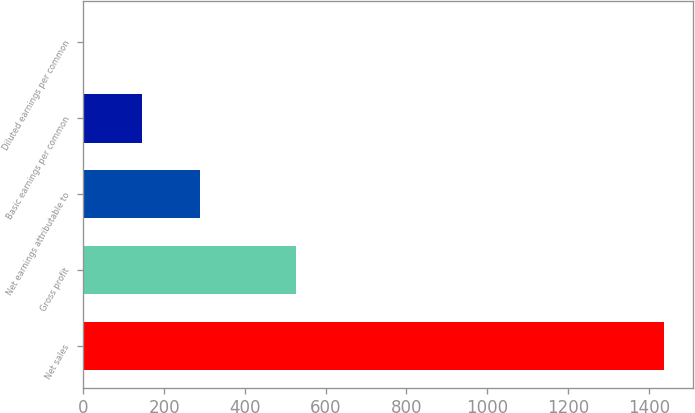Convert chart to OTSL. <chart><loc_0><loc_0><loc_500><loc_500><bar_chart><fcel>Net sales<fcel>Gross profit<fcel>Net earnings attributable to<fcel>Basic earnings per common<fcel>Diluted earnings per common<nl><fcel>1437<fcel>526.1<fcel>288.55<fcel>144.99<fcel>1.43<nl></chart> 